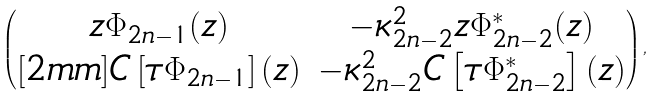Convert formula to latex. <formula><loc_0><loc_0><loc_500><loc_500>\begin{pmatrix} z \Phi _ { 2 n - 1 } ( z ) & - \kappa ^ { 2 } _ { 2 n - 2 } z \Phi ^ { * } _ { 2 n - 2 } ( z ) \\ [ 2 m m ] C \left [ \tau \Phi _ { 2 n - 1 } \right ] ( z ) & - \kappa ^ { 2 } _ { 2 n - 2 } C \left [ \tau \Phi ^ { * } _ { 2 n - 2 } \right ] ( z ) \\ \end{pmatrix} ,</formula> 